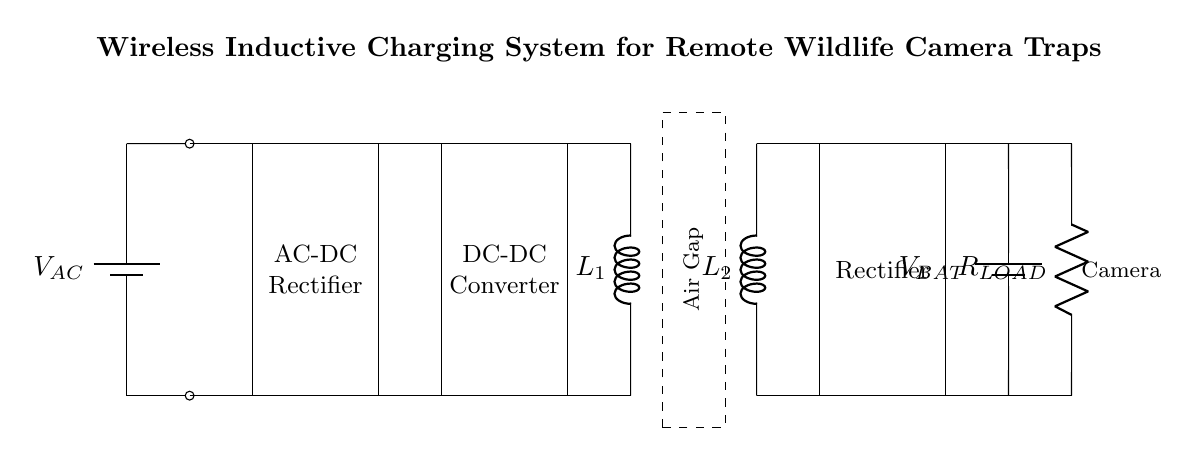What is the role of the battery in this circuit? The battery provides the necessary power for the camera load, storing energy that can be used when the system is not charging. It is represented by the component labeled V_BAT, which is connected to the camera load.
Answer: Power source What type of coils are used in this circuit? The coils in this circuit are inductive components. They are identified by the labels L_1 and L_2, which represent the transmitter and receiver coils, respectively.
Answer: Inductive How is AC converted to DC in this circuit? The circuit includes an AC-DC rectifier, as indicated by the labeled rectangle component. The rectifier converts alternating current (AC) from the battery into direct current (DC) for the charging system.
Answer: Rectifier What is the purpose of the air gap component in the circuit? The air gap component indicates the spatial separation between the transmitter coil L_1 and the receiver coil L_2, which is crucial for wireless energy transfer via inductive coupling.
Answer: Wireless energy transfer Explain the significance of the rectifier after the receiver coil. This rectifier's role is to convert the AC induced in the receiver coil L_2 back to DC, which is necessary for charging the battery (V_BAT) and supplying the camera load. This step is essential for the camera to operate correctly as modern electronics typically require a stable DC voltage.
Answer: AC to DC conversion 